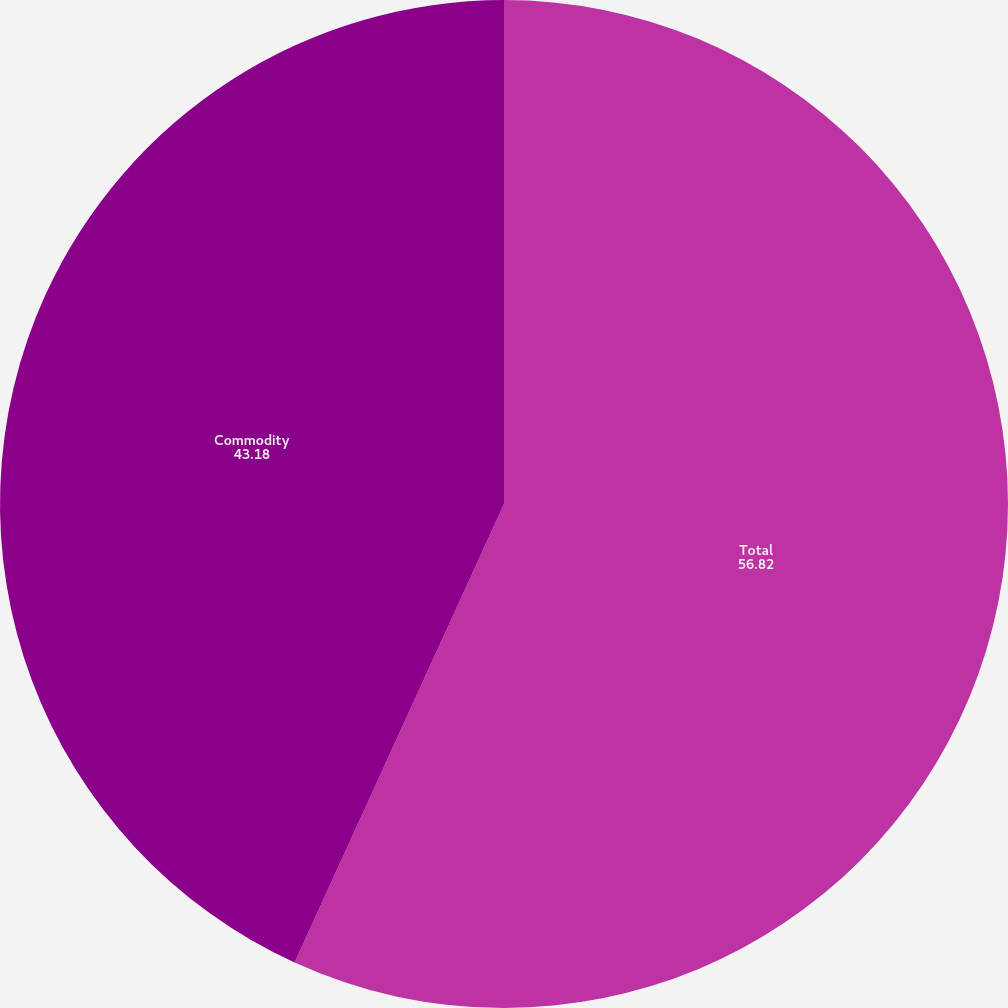Convert chart to OTSL. <chart><loc_0><loc_0><loc_500><loc_500><pie_chart><fcel>Total<fcel>Commodity<nl><fcel>56.82%<fcel>43.18%<nl></chart> 